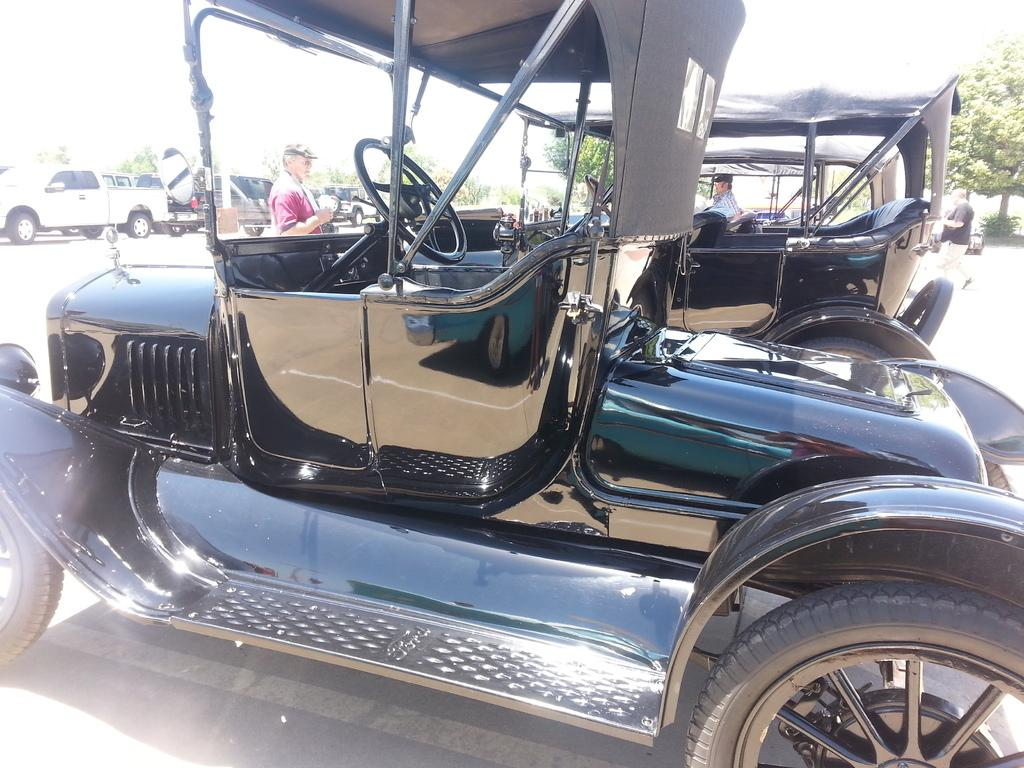What can be seen in the image related to transportation? There are vehicles parked in the image. Are there any people present in the image? Yes, there is a person standing on the road and a person sitting in a vehicle in the image. What can be seen in the background of the image? There are trees visible in the background of the image. How many secretaries are present in the image? There is no mention of secretaries in the image, so we cannot determine their presence. What are the sisters doing in the image? There is no mention of sisters in the image, so we cannot determine their presence or actions. 